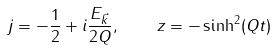Convert formula to latex. <formula><loc_0><loc_0><loc_500><loc_500>j = - \frac { 1 } { 2 } + i \frac { E _ { \vec { k } } } { 2 Q } , \quad z = - \sinh ^ { 2 } ( Q t )</formula> 